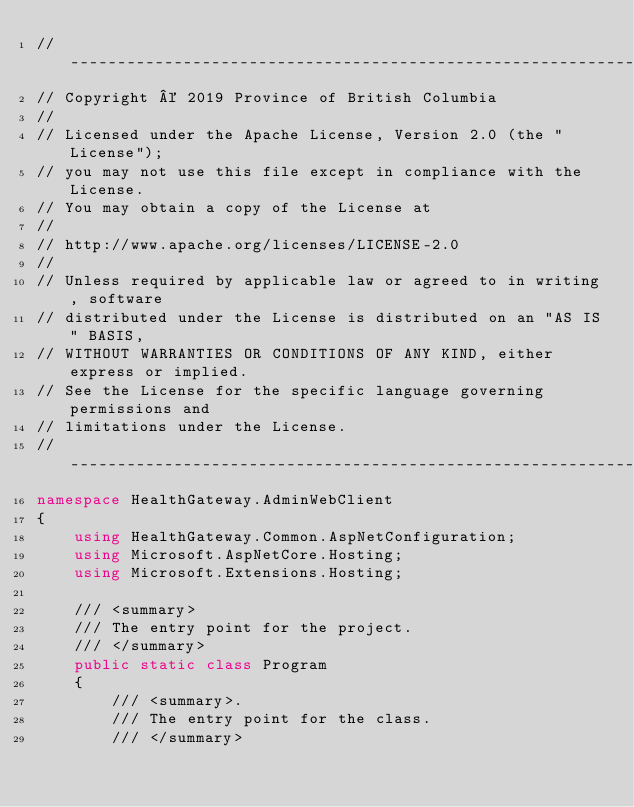<code> <loc_0><loc_0><loc_500><loc_500><_C#_>//-------------------------------------------------------------------------
// Copyright © 2019 Province of British Columbia
//
// Licensed under the Apache License, Version 2.0 (the "License");
// you may not use this file except in compliance with the License.
// You may obtain a copy of the License at
//
// http://www.apache.org/licenses/LICENSE-2.0
//
// Unless required by applicable law or agreed to in writing, software
// distributed under the License is distributed on an "AS IS" BASIS,
// WITHOUT WARRANTIES OR CONDITIONS OF ANY KIND, either express or implied.
// See the License for the specific language governing permissions and
// limitations under the License.
//-------------------------------------------------------------------------
namespace HealthGateway.AdminWebClient
{
    using HealthGateway.Common.AspNetConfiguration;
    using Microsoft.AspNetCore.Hosting;
    using Microsoft.Extensions.Hosting;

    /// <summary>
    /// The entry point for the project.
    /// </summary>
    public static class Program
    {
        /// <summary>.
        /// The entry point for the class.
        /// </summary></code> 